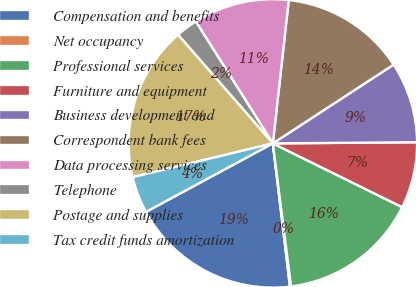Convert chart. <chart><loc_0><loc_0><loc_500><loc_500><pie_chart><fcel>Compensation and benefits<fcel>Net occupancy<fcel>Professional services<fcel>Furniture and equipment<fcel>Business development and<fcel>Correspondent bank fees<fcel>Data processing services<fcel>Telephone<fcel>Postage and supplies<fcel>Tax credit funds amortization<nl><fcel>19.01%<fcel>0.13%<fcel>15.69%<fcel>7.42%<fcel>9.07%<fcel>14.04%<fcel>10.73%<fcel>2.45%<fcel>17.35%<fcel>4.11%<nl></chart> 